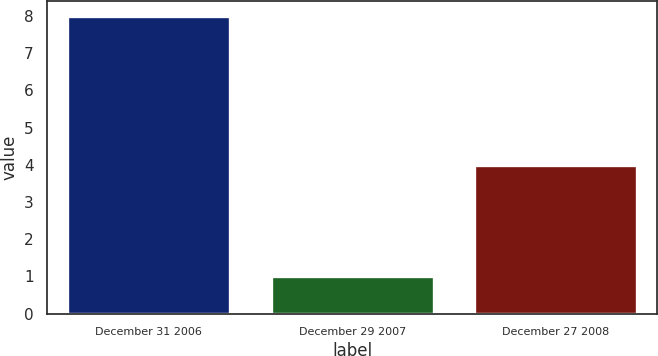<chart> <loc_0><loc_0><loc_500><loc_500><bar_chart><fcel>December 31 2006<fcel>December 29 2007<fcel>December 27 2008<nl><fcel>8<fcel>1<fcel>4<nl></chart> 